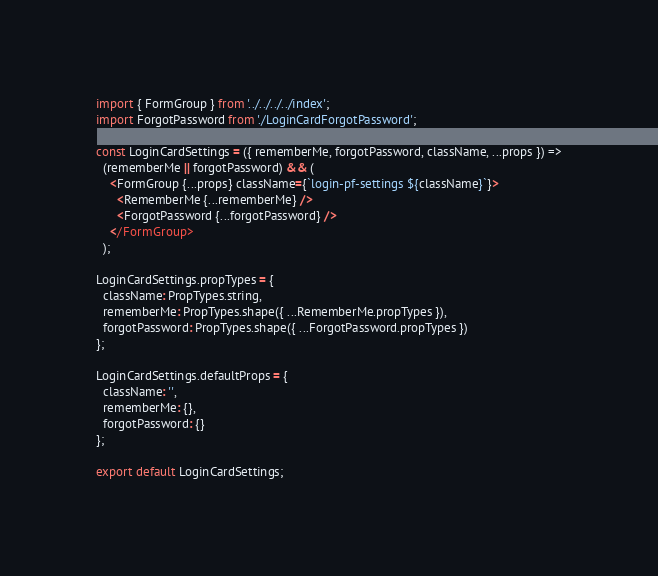Convert code to text. <code><loc_0><loc_0><loc_500><loc_500><_JavaScript_>import { FormGroup } from '../../../../index';
import ForgotPassword from './LoginCardForgotPassword';

const LoginCardSettings = ({ rememberMe, forgotPassword, className, ...props }) =>
  (rememberMe || forgotPassword) && (
    <FormGroup {...props} className={`login-pf-settings ${className}`}>
      <RememberMe {...rememberMe} />
      <ForgotPassword {...forgotPassword} />
    </FormGroup>
  );

LoginCardSettings.propTypes = {
  className: PropTypes.string,
  rememberMe: PropTypes.shape({ ...RememberMe.propTypes }),
  forgotPassword: PropTypes.shape({ ...ForgotPassword.propTypes })
};

LoginCardSettings.defaultProps = {
  className: '',
  rememberMe: {},
  forgotPassword: {}
};

export default LoginCardSettings;
</code> 